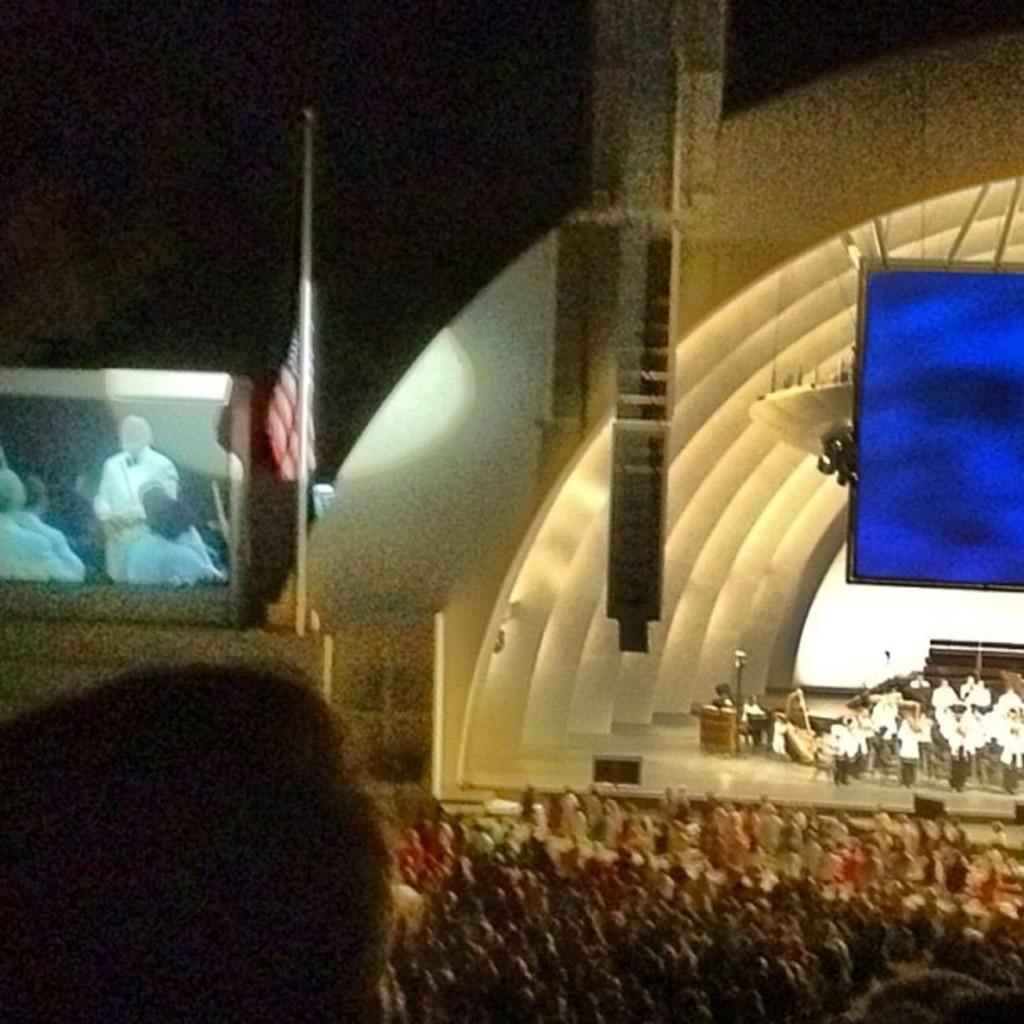Can you describe this image briefly? people standing on the stage and there are spectators sitting on the chairs. Beside there is a projector screen and there is a flag beside it. 